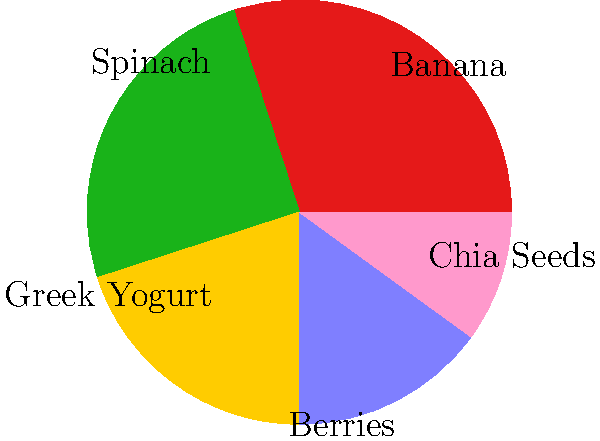Based on the pie chart showing the proportions of ingredients in a smoothie, which two ingredients contribute the most to the nutritional value while keeping preparation time minimal? To answer this question, we need to consider both the nutritional value and the preparation time of each ingredient:

1. Banana (30%): High in potassium and fiber, easy to add.
2. Spinach (25%): Rich in vitamins and minerals, requires minimal prep.
3. Greek Yogurt (20%): High in protein and probiotics, easy to add.
4. Berries (15%): Rich in antioxidants, may require washing.
5. Chia Seeds (10%): High in omega-3s and fiber, no prep needed.

Considering nutritional density and ease of preparation:

1. Spinach offers the highest nutrient density (vitamins, minerals, and antioxidants) and requires minimal prep (can be pre-washed).
2. Greek Yogurt provides high protein content and probiotics, crucial for a balanced breakfast, and is easy to add.

These two ingredients offer the best combination of high nutritional value and minimal preparation time, making them ideal for a health-conscious person who dislikes spending too much time on breakfast.
Answer: Spinach and Greek Yogurt 